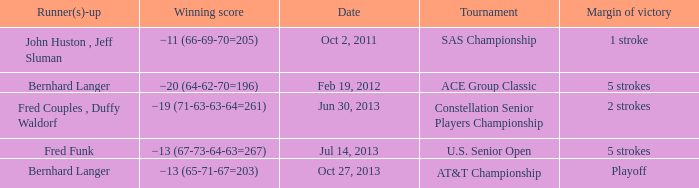Which Tournament has a Date of jul 14, 2013? U.S. Senior Open. 